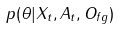<formula> <loc_0><loc_0><loc_500><loc_500>p ( \theta | X _ { t } , A _ { t } , O _ { f g } )</formula> 